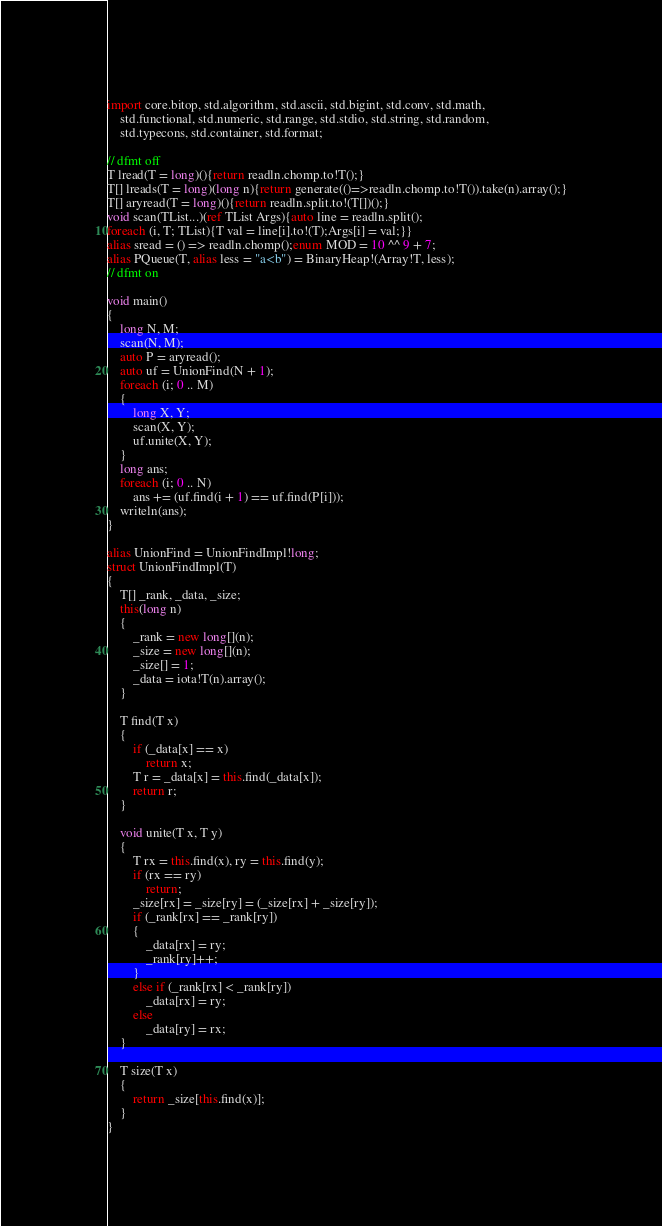Convert code to text. <code><loc_0><loc_0><loc_500><loc_500><_D_>import core.bitop, std.algorithm, std.ascii, std.bigint, std.conv, std.math,
    std.functional, std.numeric, std.range, std.stdio, std.string, std.random,
    std.typecons, std.container, std.format;

// dfmt off
T lread(T = long)(){return readln.chomp.to!T();}
T[] lreads(T = long)(long n){return generate(()=>readln.chomp.to!T()).take(n).array();}
T[] aryread(T = long)(){return readln.split.to!(T[])();}
void scan(TList...)(ref TList Args){auto line = readln.split();
foreach (i, T; TList){T val = line[i].to!(T);Args[i] = val;}}
alias sread = () => readln.chomp();enum MOD = 10 ^^ 9 + 7;
alias PQueue(T, alias less = "a<b") = BinaryHeap!(Array!T, less);
// dfmt on

void main()
{
    long N, M;
    scan(N, M);
    auto P = aryread();
    auto uf = UnionFind(N + 1);
    foreach (i; 0 .. M)
    {
        long X, Y;
        scan(X, Y);
        uf.unite(X, Y);
    }
    long ans;
    foreach (i; 0 .. N)
        ans += (uf.find(i + 1) == uf.find(P[i]));
    writeln(ans);
}

alias UnionFind = UnionFindImpl!long;
struct UnionFindImpl(T)
{
    T[] _rank, _data, _size;
    this(long n)
    {
        _rank = new long[](n);
        _size = new long[](n);
        _size[] = 1;
        _data = iota!T(n).array();
    }

    T find(T x)
    {
        if (_data[x] == x)
            return x;
        T r = _data[x] = this.find(_data[x]);
        return r;
    }

    void unite(T x, T y)
    {
        T rx = this.find(x), ry = this.find(y);
        if (rx == ry)
            return;
        _size[rx] = _size[ry] = (_size[rx] + _size[ry]);
        if (_rank[rx] == _rank[ry])
        {
            _data[rx] = ry;
            _rank[ry]++;
        }
        else if (_rank[rx] < _rank[ry])
            _data[rx] = ry;
        else
            _data[ry] = rx;
    }

    T size(T x)
    {
        return _size[this.find(x)];
    }
}
</code> 